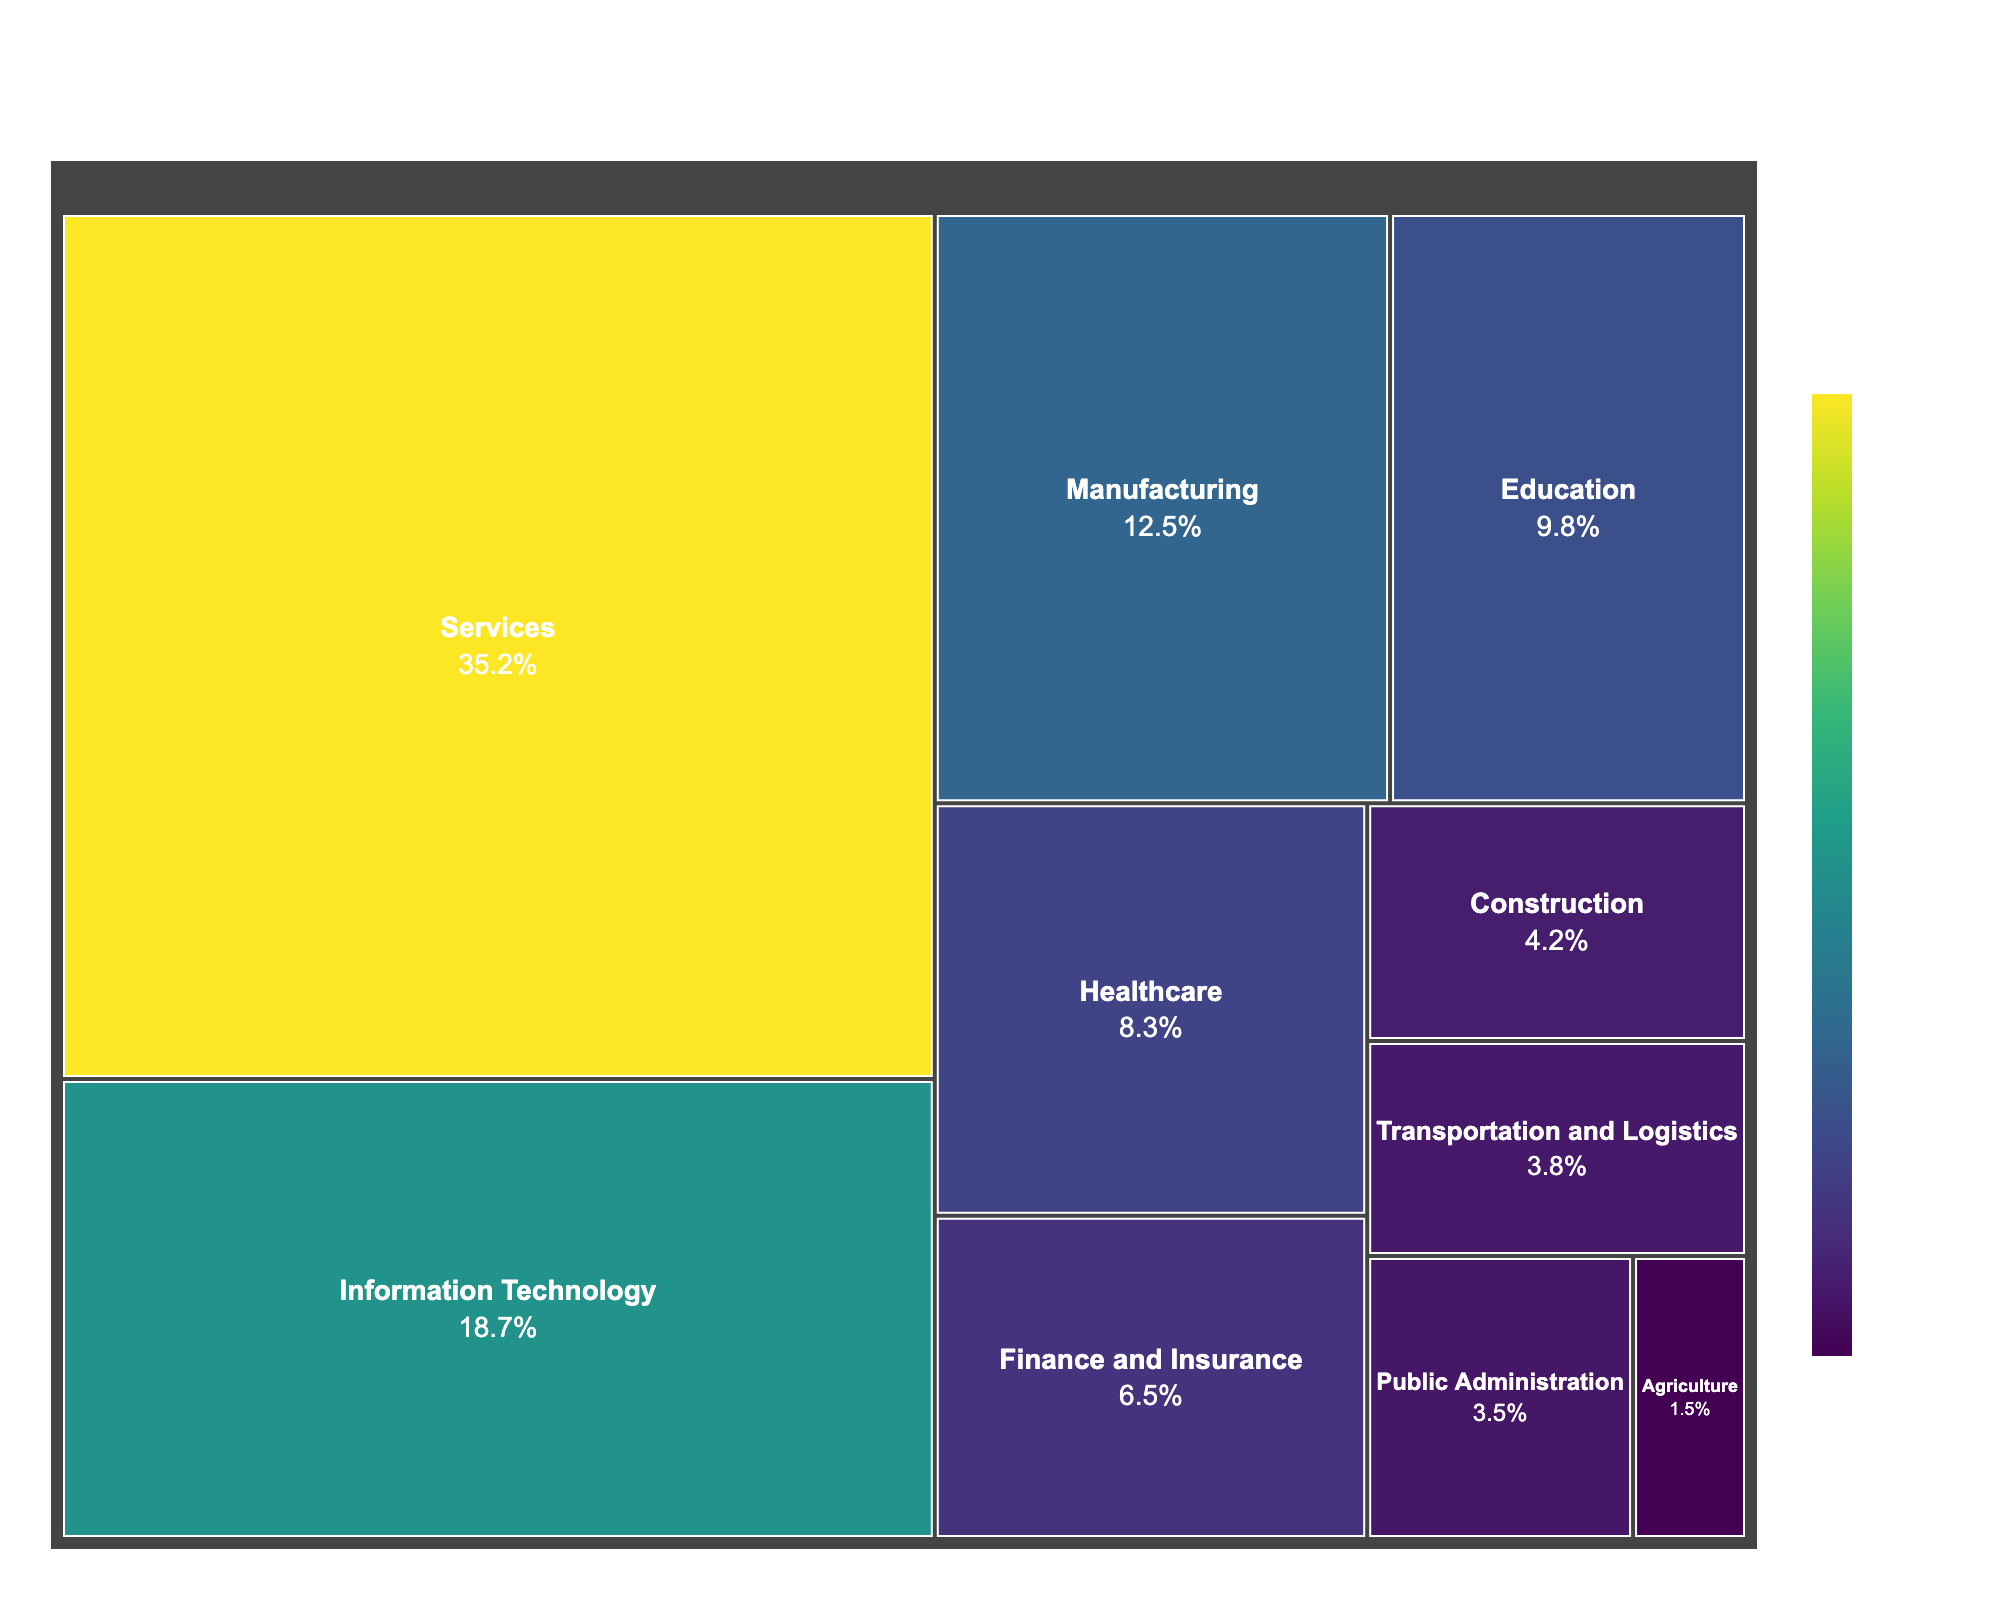What's the overall title of the treemap? The overall title of the treemap is displayed at the top of the figure, making it easy to identify.
Answer: Composition of Local Workforce by Industry Sector in Kraków Metropolitan Area Which industry sector has the largest percentage of the local workforce? Look for the largest block on the treemap, which represents the industry sector with the highest percentage.
Answer: Services What percentage of the local workforce are employed in the Information Technology sector? Find the block labeled "Information Technology" and check its corresponding percentage value.
Answer: 18.7% What is the combined percentage of the local workforce employed in Education and Healthcare sectors? Locate the percentages of both the Education (9.8%) and Healthcare (8.3%) sectors and sum them up: 9.8% + 8.3% = 18.1%
Answer: 18.1% Is the percentage of people employed in Public Administration higher or lower than in Finance and Insurance? Compare the blocks labeled "Public Administration" (3.5%) and "Finance and Insurance" (6.5%) to determine which is larger.
Answer: Lower Which industry sector occupies a smaller percentage: Construction or Transportation and Logistics? Compare the percentages of "Construction" (4.2%) and "Transportation and Logistics" (3.8%) to identify the smaller value.
Answer: Transportation and Logistics How many industry sectors have a workforce percentage greater than 10%? Identify all blocks with percentages greater than 10%: Services (35.2%), Information Technology (18.7%), and Manufacturing (12.5%).
Answer: Three sectors What is the difference in workforce percentage between the largest and smallest sectors? Subtract the smallest sector's percentage (Agriculture, 1.5%) from the largest sector's percentage (Services, 35.2%): 35.2% - 1.5% = 33.7%
Answer: 33.7% Which sector is directly less prevalent than Healthcare? Find the sector with a percentage immediately below Healthcare (8.3%). The next lower percentage block is Finance and Insurance (6.5%).
Answer: Finance and Insurance If the workforce in Services were to decrease by 10%, what would be the new percentage? Subtract 10% from the current Services percentage: 35.2% - 10% = 25.2%
Answer: 25.2% 